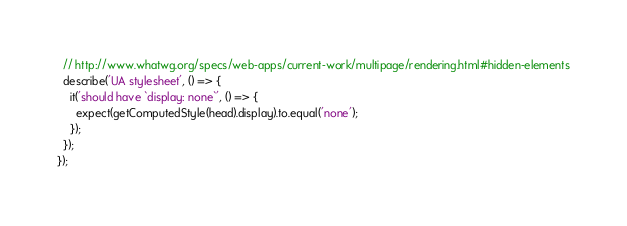<code> <loc_0><loc_0><loc_500><loc_500><_JavaScript_>
  // http://www.whatwg.org/specs/web-apps/current-work/multipage/rendering.html#hidden-elements
  describe('UA stylesheet', () => {
    it('should have `display: none`', () => {
      expect(getComputedStyle(head).display).to.equal('none');
    });
  });
});
</code> 